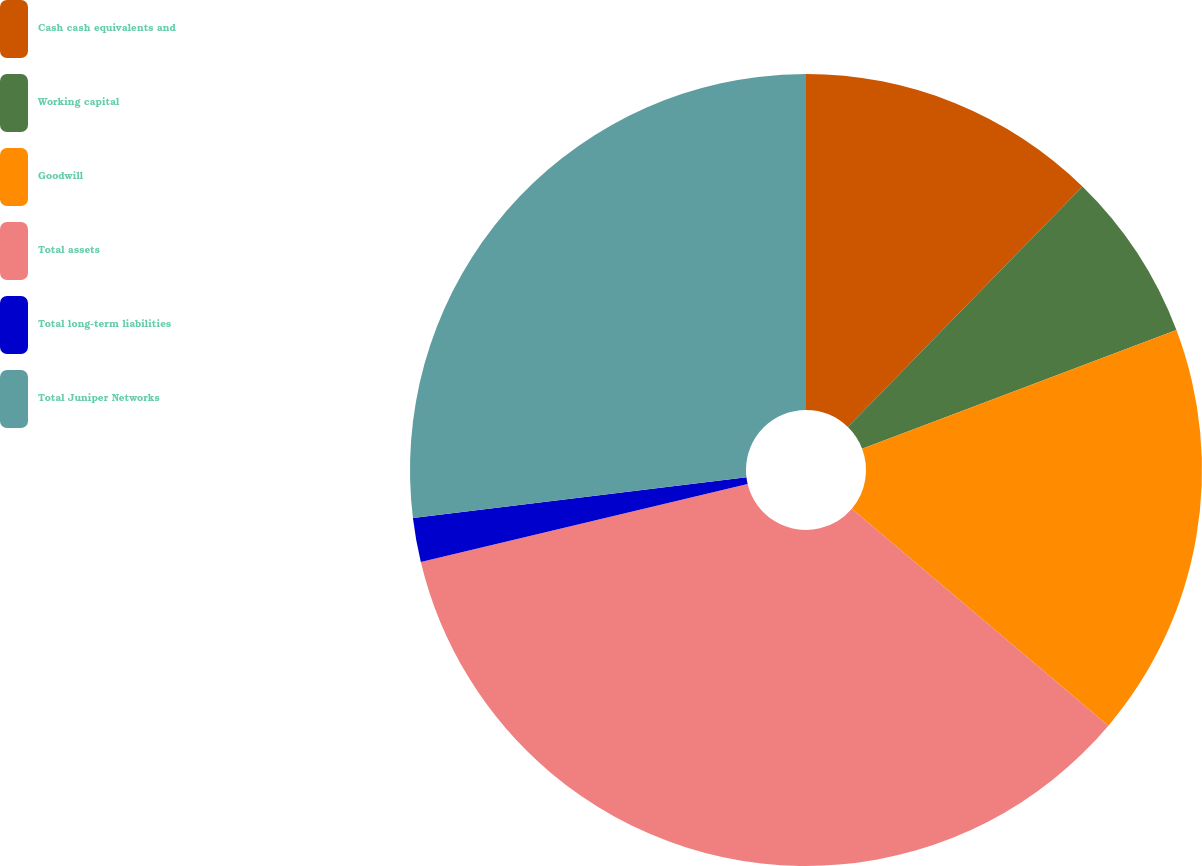Convert chart. <chart><loc_0><loc_0><loc_500><loc_500><pie_chart><fcel>Cash cash equivalents and<fcel>Working capital<fcel>Goodwill<fcel>Total assets<fcel>Total long-term liabilities<fcel>Total Juniper Networks<nl><fcel>12.3%<fcel>6.95%<fcel>16.92%<fcel>35.1%<fcel>1.8%<fcel>26.93%<nl></chart> 